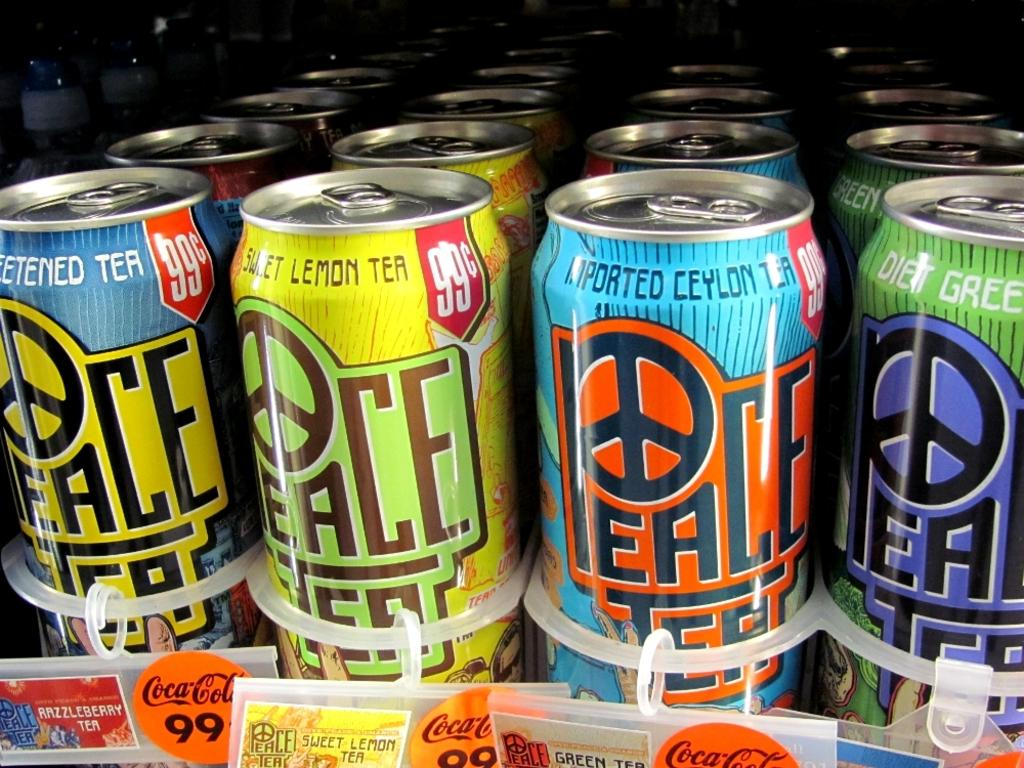<image>
Present a compact description of the photo's key features. a colorful display of aluminum cans of peace tea drinks 